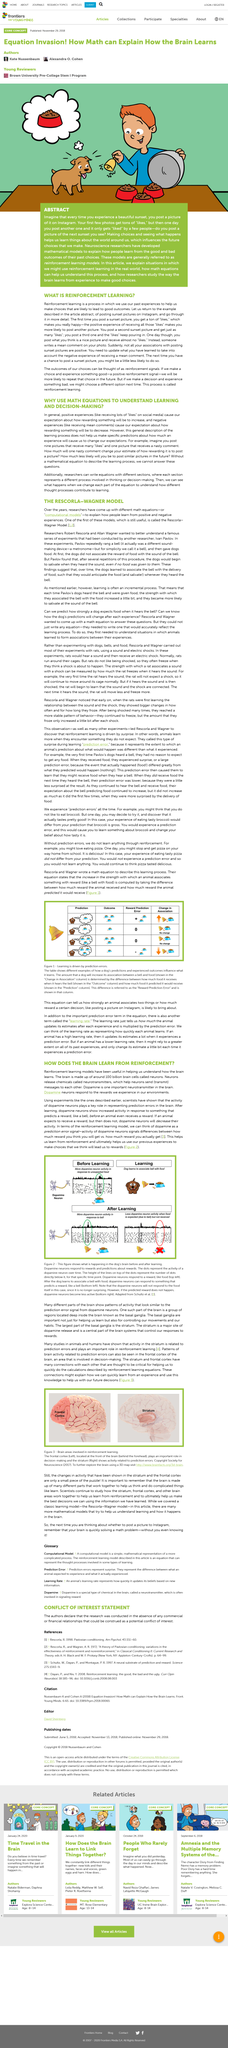Specify some key components in this picture. The process of learning involves the brain receiving information through reinforcement, leading to the formation of new connections and patterns in the brain. The top image depicts a dog engaging in reinforcement learning, where it adjusts its behavior based on the consequences of its actions. Researchers in the field of neuroscience have developed reinforcement learning models. Dopamine influences reward-motivated behaviour. Reinforcement Learning models are mathematical models used to explain how people learn from the consequences of their past choices, and are generally referred to as models of learning from past outcomes. 